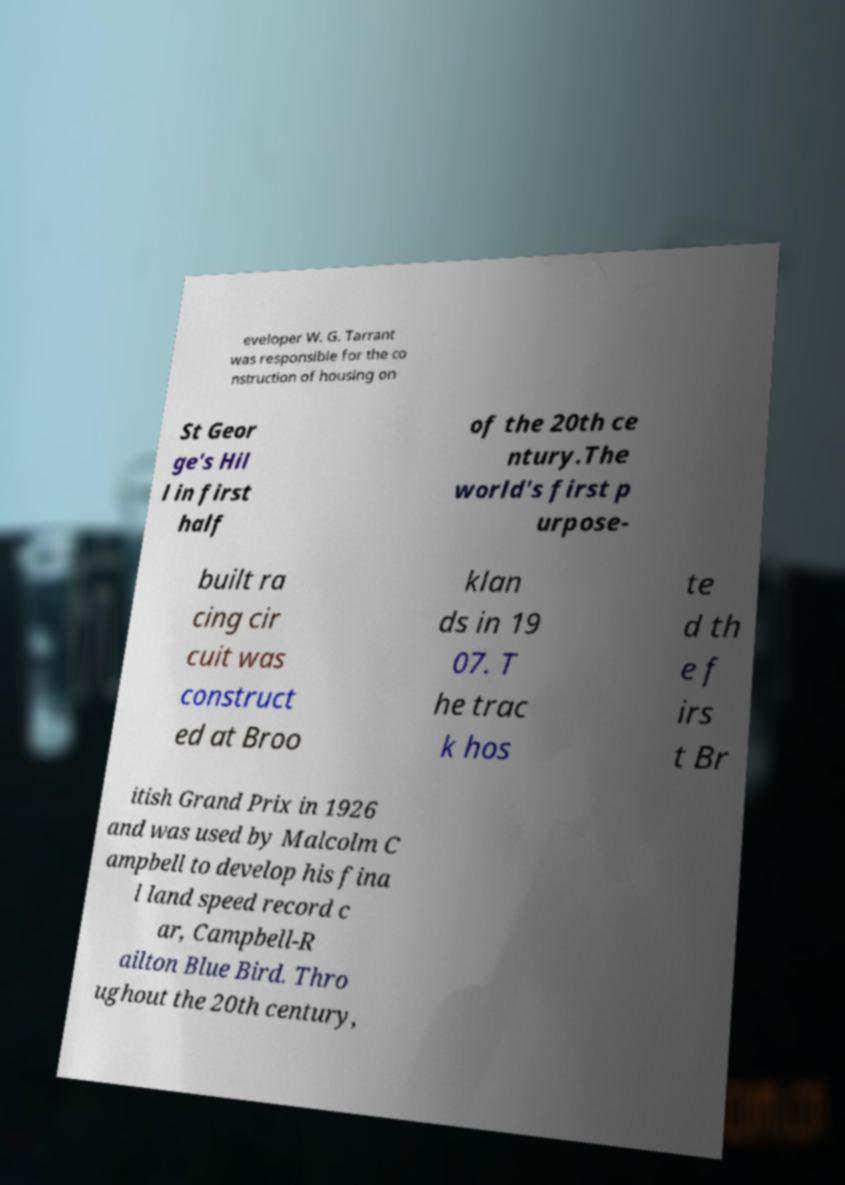Could you extract and type out the text from this image? eveloper W. G. Tarrant was responsible for the co nstruction of housing on St Geor ge's Hil l in first half of the 20th ce ntury.The world's first p urpose- built ra cing cir cuit was construct ed at Broo klan ds in 19 07. T he trac k hos te d th e f irs t Br itish Grand Prix in 1926 and was used by Malcolm C ampbell to develop his fina l land speed record c ar, Campbell-R ailton Blue Bird. Thro ughout the 20th century, 